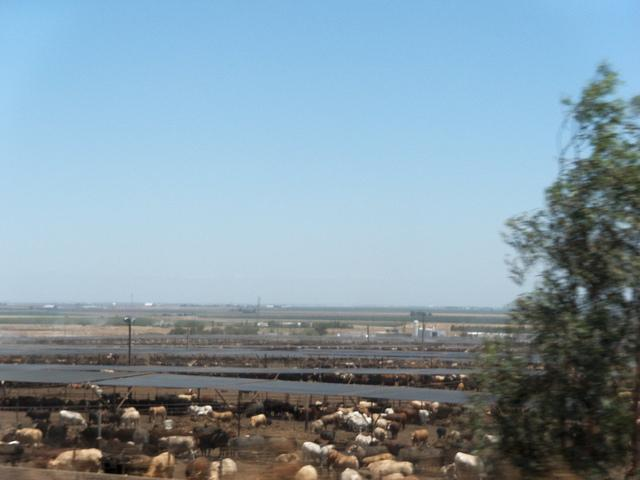What danger does the fence at the back of the lot protect the cows from? escaping 